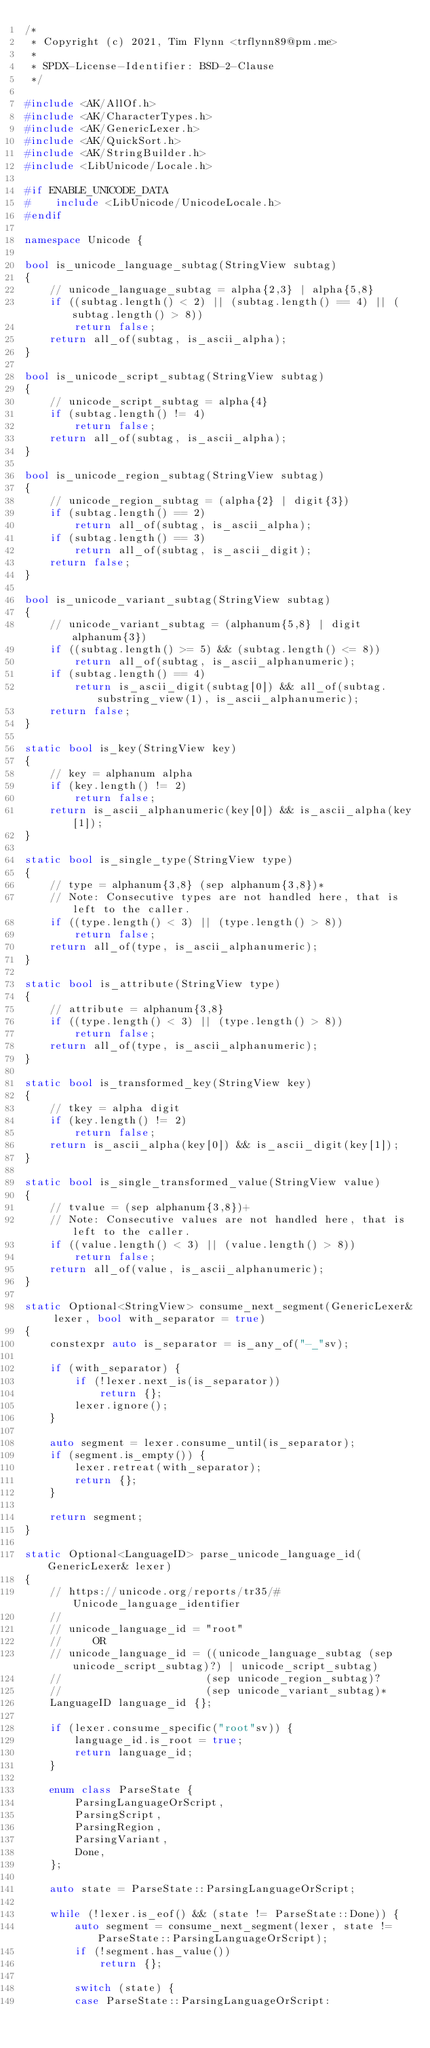<code> <loc_0><loc_0><loc_500><loc_500><_C++_>/*
 * Copyright (c) 2021, Tim Flynn <trflynn89@pm.me>
 *
 * SPDX-License-Identifier: BSD-2-Clause
 */

#include <AK/AllOf.h>
#include <AK/CharacterTypes.h>
#include <AK/GenericLexer.h>
#include <AK/QuickSort.h>
#include <AK/StringBuilder.h>
#include <LibUnicode/Locale.h>

#if ENABLE_UNICODE_DATA
#    include <LibUnicode/UnicodeLocale.h>
#endif

namespace Unicode {

bool is_unicode_language_subtag(StringView subtag)
{
    // unicode_language_subtag = alpha{2,3} | alpha{5,8}
    if ((subtag.length() < 2) || (subtag.length() == 4) || (subtag.length() > 8))
        return false;
    return all_of(subtag, is_ascii_alpha);
}

bool is_unicode_script_subtag(StringView subtag)
{
    // unicode_script_subtag = alpha{4}
    if (subtag.length() != 4)
        return false;
    return all_of(subtag, is_ascii_alpha);
}

bool is_unicode_region_subtag(StringView subtag)
{
    // unicode_region_subtag = (alpha{2} | digit{3})
    if (subtag.length() == 2)
        return all_of(subtag, is_ascii_alpha);
    if (subtag.length() == 3)
        return all_of(subtag, is_ascii_digit);
    return false;
}

bool is_unicode_variant_subtag(StringView subtag)
{
    // unicode_variant_subtag = (alphanum{5,8} | digit alphanum{3})
    if ((subtag.length() >= 5) && (subtag.length() <= 8))
        return all_of(subtag, is_ascii_alphanumeric);
    if (subtag.length() == 4)
        return is_ascii_digit(subtag[0]) && all_of(subtag.substring_view(1), is_ascii_alphanumeric);
    return false;
}

static bool is_key(StringView key)
{
    // key = alphanum alpha
    if (key.length() != 2)
        return false;
    return is_ascii_alphanumeric(key[0]) && is_ascii_alpha(key[1]);
}

static bool is_single_type(StringView type)
{
    // type = alphanum{3,8} (sep alphanum{3,8})*
    // Note: Consecutive types are not handled here, that is left to the caller.
    if ((type.length() < 3) || (type.length() > 8))
        return false;
    return all_of(type, is_ascii_alphanumeric);
}

static bool is_attribute(StringView type)
{
    // attribute = alphanum{3,8}
    if ((type.length() < 3) || (type.length() > 8))
        return false;
    return all_of(type, is_ascii_alphanumeric);
}

static bool is_transformed_key(StringView key)
{
    // tkey = alpha digit
    if (key.length() != 2)
        return false;
    return is_ascii_alpha(key[0]) && is_ascii_digit(key[1]);
}

static bool is_single_transformed_value(StringView value)
{
    // tvalue = (sep alphanum{3,8})+
    // Note: Consecutive values are not handled here, that is left to the caller.
    if ((value.length() < 3) || (value.length() > 8))
        return false;
    return all_of(value, is_ascii_alphanumeric);
}

static Optional<StringView> consume_next_segment(GenericLexer& lexer, bool with_separator = true)
{
    constexpr auto is_separator = is_any_of("-_"sv);

    if (with_separator) {
        if (!lexer.next_is(is_separator))
            return {};
        lexer.ignore();
    }

    auto segment = lexer.consume_until(is_separator);
    if (segment.is_empty()) {
        lexer.retreat(with_separator);
        return {};
    }

    return segment;
}

static Optional<LanguageID> parse_unicode_language_id(GenericLexer& lexer)
{
    // https://unicode.org/reports/tr35/#Unicode_language_identifier
    //
    // unicode_language_id = "root"
    //     OR
    // unicode_language_id = ((unicode_language_subtag (sep unicode_script_subtag)?) | unicode_script_subtag)
    //                       (sep unicode_region_subtag)?
    //                       (sep unicode_variant_subtag)*
    LanguageID language_id {};

    if (lexer.consume_specific("root"sv)) {
        language_id.is_root = true;
        return language_id;
    }

    enum class ParseState {
        ParsingLanguageOrScript,
        ParsingScript,
        ParsingRegion,
        ParsingVariant,
        Done,
    };

    auto state = ParseState::ParsingLanguageOrScript;

    while (!lexer.is_eof() && (state != ParseState::Done)) {
        auto segment = consume_next_segment(lexer, state != ParseState::ParsingLanguageOrScript);
        if (!segment.has_value())
            return {};

        switch (state) {
        case ParseState::ParsingLanguageOrScript:</code> 